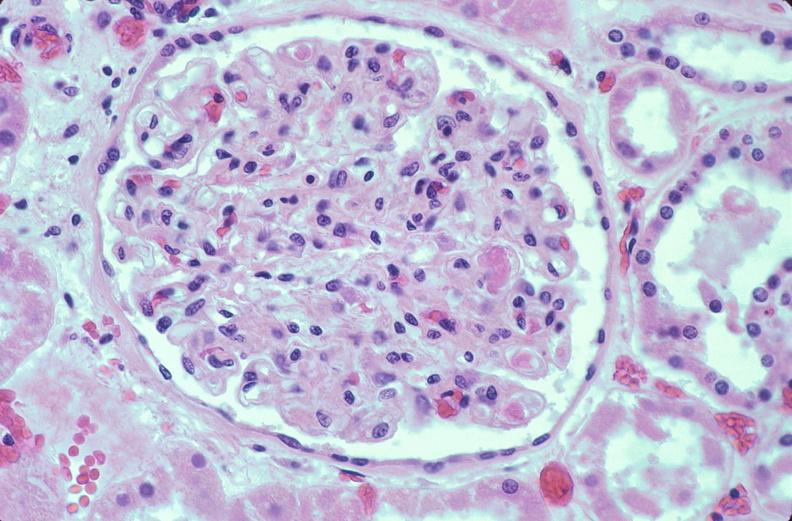what does this image show?
Answer the question using a single word or phrase. Kidney 